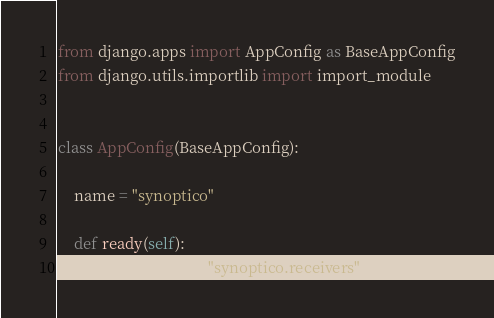Convert code to text. <code><loc_0><loc_0><loc_500><loc_500><_Python_>from django.apps import AppConfig as BaseAppConfig
from django.utils.importlib import import_module


class AppConfig(BaseAppConfig):

    name = "synoptico"

    def ready(self):
        import_module("synoptico.receivers")
</code> 